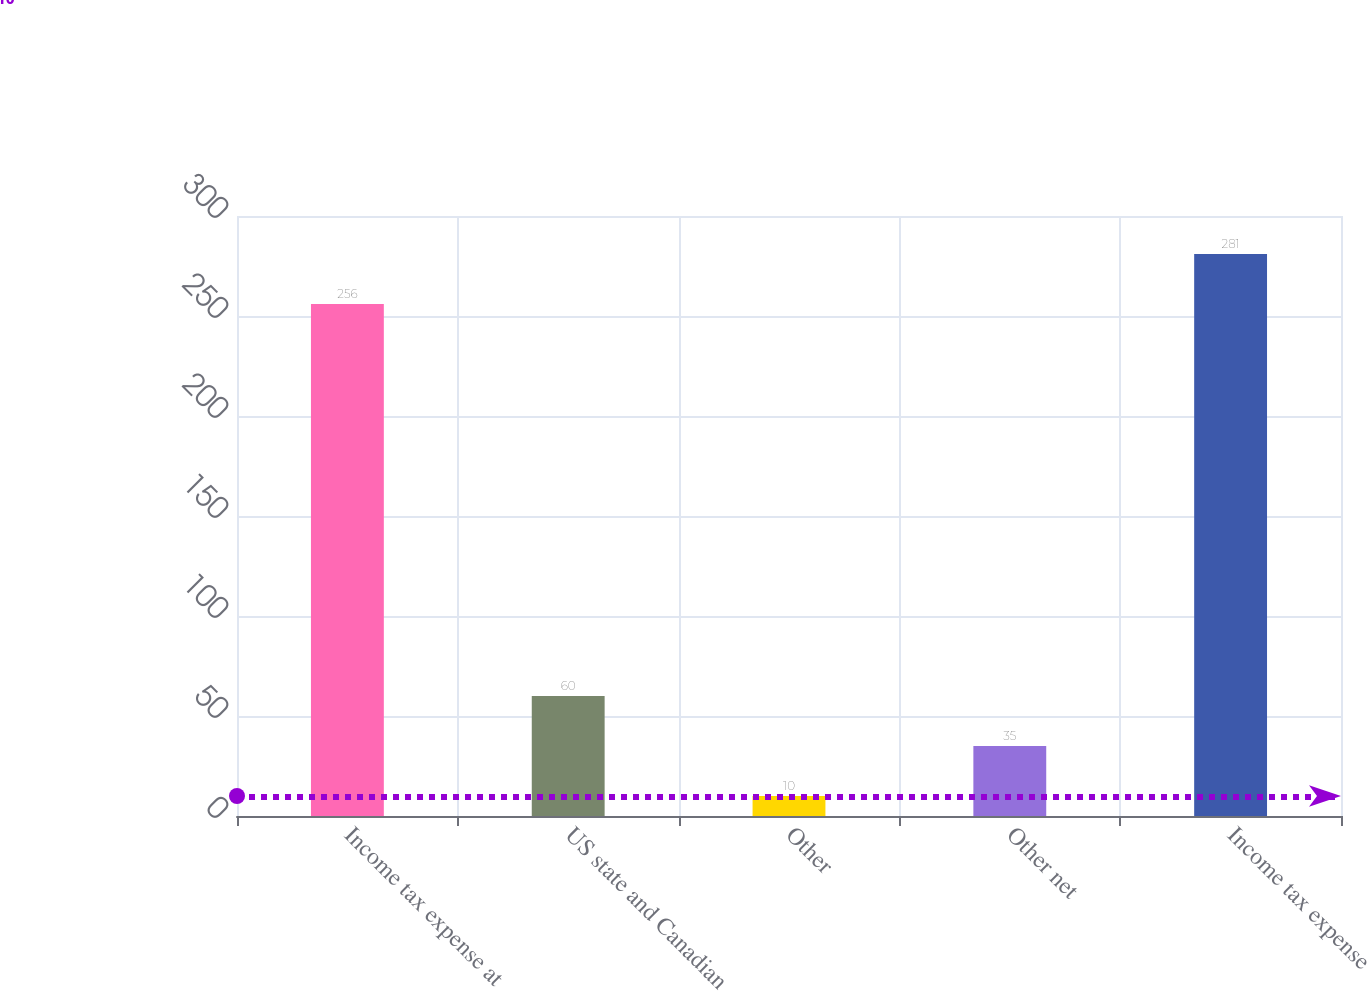Convert chart to OTSL. <chart><loc_0><loc_0><loc_500><loc_500><bar_chart><fcel>Income tax expense at<fcel>US state and Canadian<fcel>Other<fcel>Other net<fcel>Income tax expense<nl><fcel>256<fcel>60<fcel>10<fcel>35<fcel>281<nl></chart> 